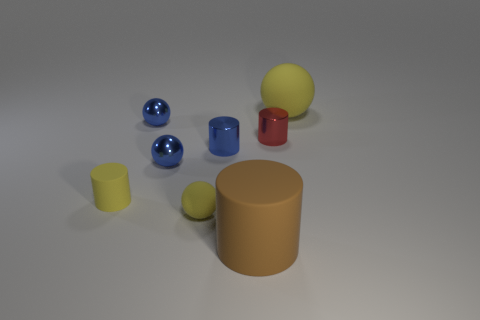Subtract all small spheres. How many spheres are left? 1 Add 1 red things. How many red things are left? 2 Add 4 cyan objects. How many cyan objects exist? 4 Add 2 tiny red objects. How many objects exist? 10 Subtract all blue cylinders. How many cylinders are left? 3 Subtract 0 red balls. How many objects are left? 8 Subtract 1 spheres. How many spheres are left? 3 Subtract all red spheres. Subtract all yellow blocks. How many spheres are left? 4 Subtract all blue spheres. How many brown cylinders are left? 1 Subtract all shiny objects. Subtract all yellow rubber objects. How many objects are left? 1 